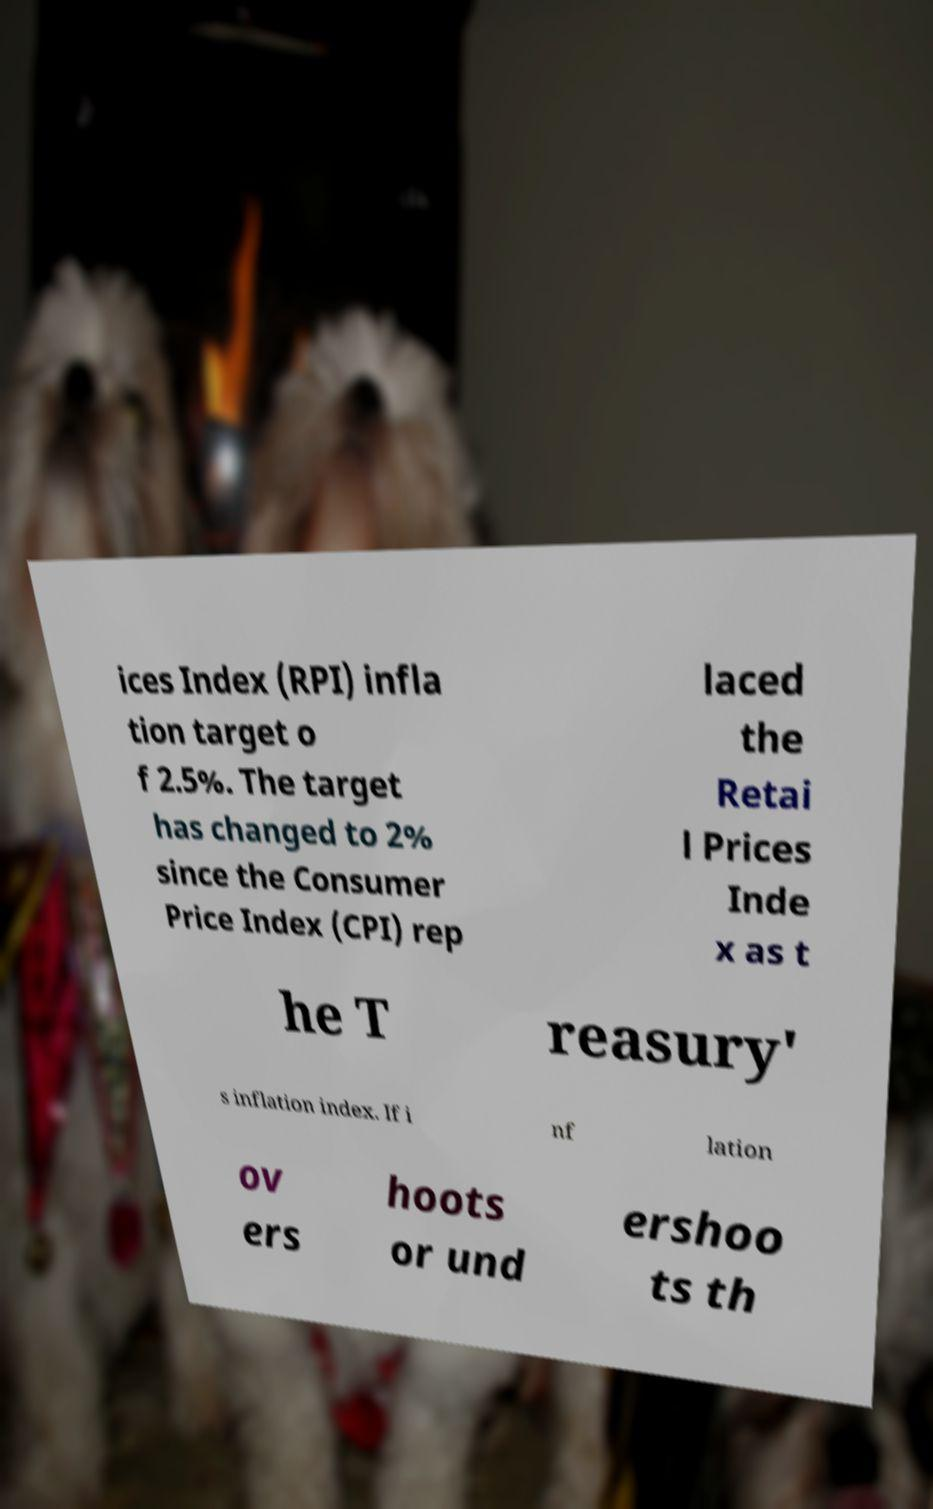Can you read and provide the text displayed in the image?This photo seems to have some interesting text. Can you extract and type it out for me? ices Index (RPI) infla tion target o f 2.5%. The target has changed to 2% since the Consumer Price Index (CPI) rep laced the Retai l Prices Inde x as t he T reasury' s inflation index. If i nf lation ov ers hoots or und ershoo ts th 